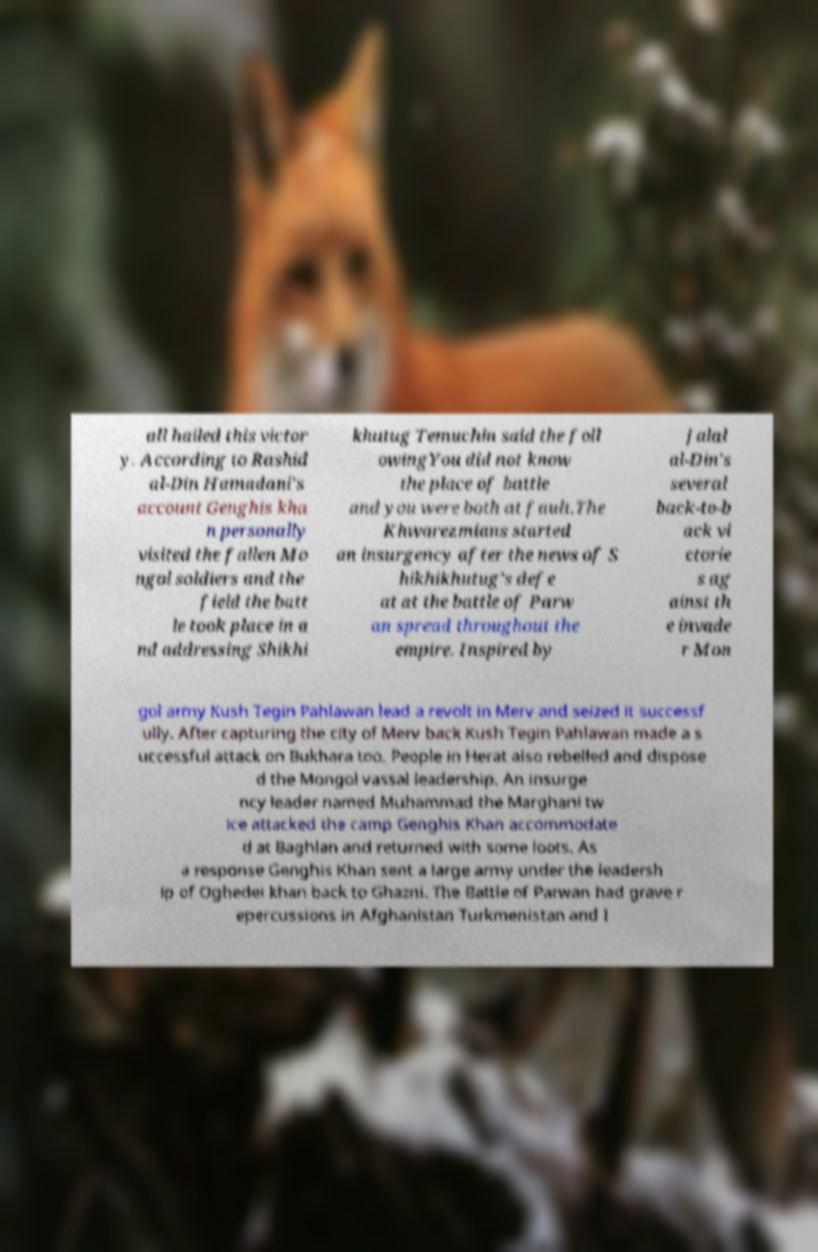What messages or text are displayed in this image? I need them in a readable, typed format. all hailed this victor y. According to Rashid al-Din Hamadani's account Genghis kha n personally visited the fallen Mo ngol soldiers and the field the batt le took place in a nd addressing Shikhi khutug Temuchin said the foll owingYou did not know the place of battle and you were both at fault.The Khwarezmians started an insurgency after the news of S hikhikhutug's defe at at the battle of Parw an spread throughout the empire. Inspired by Jalal al-Din's several back-to-b ack vi ctorie s ag ainst th e invade r Mon gol army Kush Tegin Pahlawan lead a revolt in Merv and seized it successf ully. After capturing the city of Merv back Kush Tegin Pahlawan made a s uccessful attack on Bukhara too. People in Herat also rebelled and dispose d the Mongol vassal leadership. An insurge ncy leader named Muhammad the Marghani tw ice attacked the camp Genghis Khan accommodate d at Baghlan and returned with some loots. As a response Genghis Khan sent a large army under the leadersh ip of Oghedei khan back to Ghazni. The Battle of Parwan had grave r epercussions in Afghanistan Turkmenistan and I 